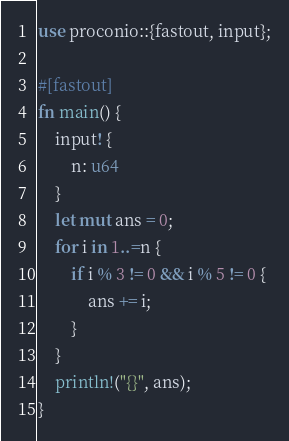<code> <loc_0><loc_0><loc_500><loc_500><_Rust_>use proconio::{fastout, input};

#[fastout]
fn main() {
    input! {
        n: u64
    }
    let mut ans = 0;
    for i in 1..=n {
        if i % 3 != 0 && i % 5 != 0 {
            ans += i;
        }
    }
    println!("{}", ans);
}
</code> 